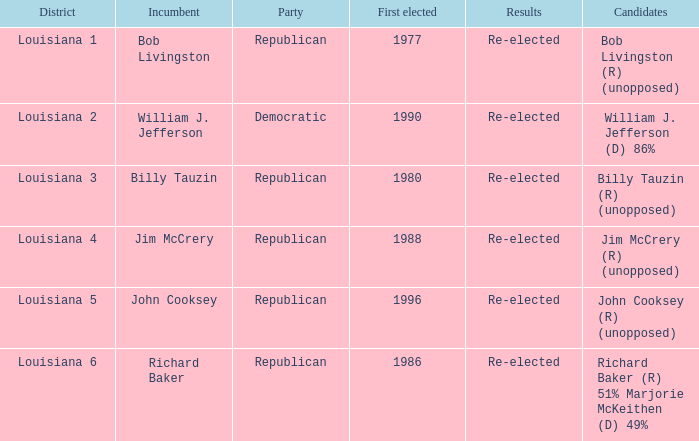Which district is represented by john cooksey? Louisiana 5. 